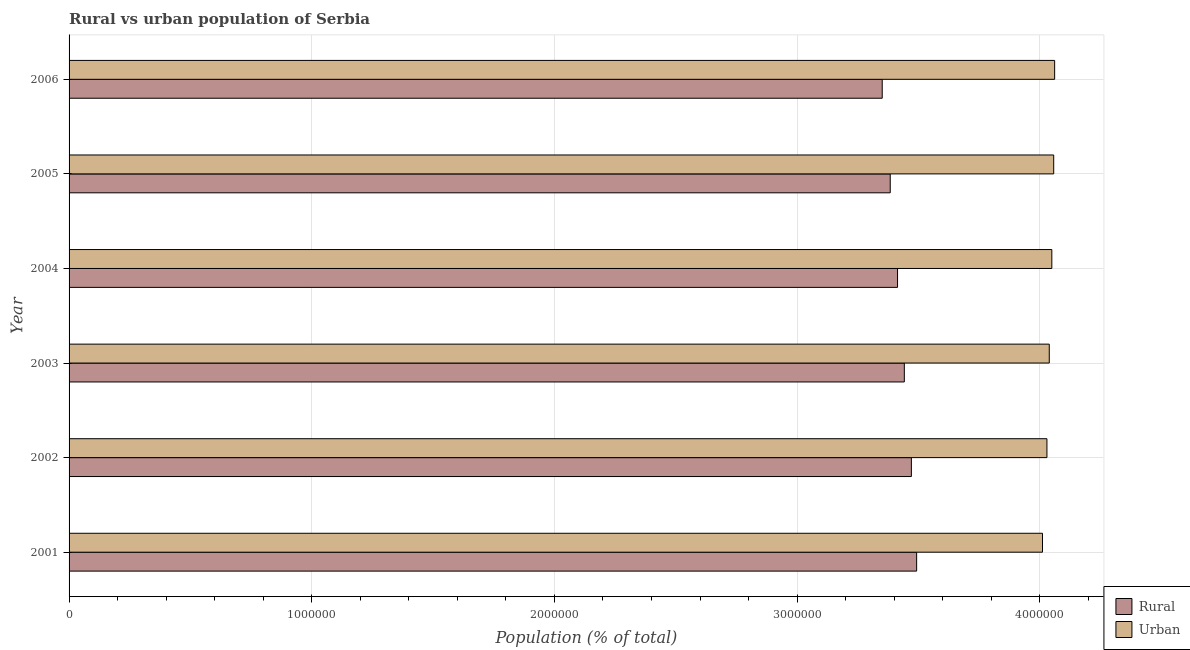How many groups of bars are there?
Offer a terse response. 6. Are the number of bars per tick equal to the number of legend labels?
Make the answer very short. Yes. Are the number of bars on each tick of the Y-axis equal?
Your answer should be compact. Yes. How many bars are there on the 1st tick from the bottom?
Your answer should be very brief. 2. What is the label of the 5th group of bars from the top?
Your answer should be very brief. 2002. In how many cases, is the number of bars for a given year not equal to the number of legend labels?
Give a very brief answer. 0. What is the urban population density in 2004?
Offer a very short reply. 4.05e+06. Across all years, what is the maximum urban population density?
Offer a terse response. 4.06e+06. Across all years, what is the minimum rural population density?
Your answer should be very brief. 3.35e+06. In which year was the urban population density maximum?
Your answer should be very brief. 2006. What is the total urban population density in the graph?
Give a very brief answer. 2.42e+07. What is the difference between the rural population density in 2001 and that in 2006?
Make the answer very short. 1.42e+05. What is the difference between the rural population density in 2004 and the urban population density in 2001?
Your answer should be very brief. -5.97e+05. What is the average urban population density per year?
Keep it short and to the point. 4.04e+06. In the year 2005, what is the difference between the urban population density and rural population density?
Your response must be concise. 6.74e+05. What is the ratio of the rural population density in 2004 to that in 2005?
Offer a very short reply. 1.01. Is the difference between the urban population density in 2001 and 2003 greater than the difference between the rural population density in 2001 and 2003?
Your response must be concise. No. What is the difference between the highest and the second highest rural population density?
Give a very brief answer. 2.17e+04. What is the difference between the highest and the lowest urban population density?
Ensure brevity in your answer.  5.00e+04. What does the 2nd bar from the top in 2006 represents?
Make the answer very short. Rural. What does the 1st bar from the bottom in 2004 represents?
Offer a very short reply. Rural. How many bars are there?
Provide a short and direct response. 12. Are all the bars in the graph horizontal?
Make the answer very short. Yes. Are the values on the major ticks of X-axis written in scientific E-notation?
Offer a terse response. No. How many legend labels are there?
Provide a short and direct response. 2. How are the legend labels stacked?
Your answer should be very brief. Vertical. What is the title of the graph?
Offer a terse response. Rural vs urban population of Serbia. Does "Urban Population" appear as one of the legend labels in the graph?
Provide a short and direct response. No. What is the label or title of the X-axis?
Make the answer very short. Population (% of total). What is the label or title of the Y-axis?
Provide a short and direct response. Year. What is the Population (% of total) in Rural in 2001?
Make the answer very short. 3.49e+06. What is the Population (% of total) of Urban in 2001?
Provide a short and direct response. 4.01e+06. What is the Population (% of total) of Rural in 2002?
Your answer should be compact. 3.47e+06. What is the Population (% of total) of Urban in 2002?
Provide a short and direct response. 4.03e+06. What is the Population (% of total) in Rural in 2003?
Offer a terse response. 3.44e+06. What is the Population (% of total) in Urban in 2003?
Your response must be concise. 4.04e+06. What is the Population (% of total) in Rural in 2004?
Your response must be concise. 3.41e+06. What is the Population (% of total) of Urban in 2004?
Your answer should be very brief. 4.05e+06. What is the Population (% of total) in Rural in 2005?
Provide a short and direct response. 3.38e+06. What is the Population (% of total) of Urban in 2005?
Your answer should be compact. 4.06e+06. What is the Population (% of total) of Rural in 2006?
Offer a terse response. 3.35e+06. What is the Population (% of total) in Urban in 2006?
Keep it short and to the point. 4.06e+06. Across all years, what is the maximum Population (% of total) in Rural?
Make the answer very short. 3.49e+06. Across all years, what is the maximum Population (% of total) in Urban?
Provide a succinct answer. 4.06e+06. Across all years, what is the minimum Population (% of total) of Rural?
Provide a succinct answer. 3.35e+06. Across all years, what is the minimum Population (% of total) of Urban?
Provide a short and direct response. 4.01e+06. What is the total Population (% of total) of Rural in the graph?
Give a very brief answer. 2.06e+07. What is the total Population (% of total) in Urban in the graph?
Make the answer very short. 2.42e+07. What is the difference between the Population (% of total) in Rural in 2001 and that in 2002?
Give a very brief answer. 2.17e+04. What is the difference between the Population (% of total) of Urban in 2001 and that in 2002?
Ensure brevity in your answer.  -1.83e+04. What is the difference between the Population (% of total) of Rural in 2001 and that in 2003?
Ensure brevity in your answer.  5.07e+04. What is the difference between the Population (% of total) in Urban in 2001 and that in 2003?
Keep it short and to the point. -2.79e+04. What is the difference between the Population (% of total) in Rural in 2001 and that in 2004?
Ensure brevity in your answer.  7.87e+04. What is the difference between the Population (% of total) of Urban in 2001 and that in 2004?
Your answer should be very brief. -3.84e+04. What is the difference between the Population (% of total) in Rural in 2001 and that in 2005?
Keep it short and to the point. 1.09e+05. What is the difference between the Population (% of total) in Urban in 2001 and that in 2005?
Provide a short and direct response. -4.61e+04. What is the difference between the Population (% of total) in Rural in 2001 and that in 2006?
Your answer should be compact. 1.42e+05. What is the difference between the Population (% of total) of Urban in 2001 and that in 2006?
Offer a terse response. -5.00e+04. What is the difference between the Population (% of total) in Rural in 2002 and that in 2003?
Provide a succinct answer. 2.90e+04. What is the difference between the Population (% of total) of Urban in 2002 and that in 2003?
Give a very brief answer. -9604. What is the difference between the Population (% of total) of Rural in 2002 and that in 2004?
Offer a terse response. 5.70e+04. What is the difference between the Population (% of total) of Urban in 2002 and that in 2004?
Your response must be concise. -2.01e+04. What is the difference between the Population (% of total) in Rural in 2002 and that in 2005?
Ensure brevity in your answer.  8.71e+04. What is the difference between the Population (% of total) in Urban in 2002 and that in 2005?
Your answer should be compact. -2.78e+04. What is the difference between the Population (% of total) of Rural in 2002 and that in 2006?
Offer a terse response. 1.20e+05. What is the difference between the Population (% of total) in Urban in 2002 and that in 2006?
Give a very brief answer. -3.17e+04. What is the difference between the Population (% of total) in Rural in 2003 and that in 2004?
Offer a very short reply. 2.79e+04. What is the difference between the Population (% of total) of Urban in 2003 and that in 2004?
Your answer should be compact. -1.05e+04. What is the difference between the Population (% of total) of Rural in 2003 and that in 2005?
Give a very brief answer. 5.81e+04. What is the difference between the Population (% of total) of Urban in 2003 and that in 2005?
Provide a short and direct response. -1.82e+04. What is the difference between the Population (% of total) of Rural in 2003 and that in 2006?
Offer a very short reply. 9.11e+04. What is the difference between the Population (% of total) in Urban in 2003 and that in 2006?
Your answer should be compact. -2.21e+04. What is the difference between the Population (% of total) of Rural in 2004 and that in 2005?
Provide a succinct answer. 3.01e+04. What is the difference between the Population (% of total) in Urban in 2004 and that in 2005?
Ensure brevity in your answer.  -7720. What is the difference between the Population (% of total) in Rural in 2004 and that in 2006?
Make the answer very short. 6.32e+04. What is the difference between the Population (% of total) of Urban in 2004 and that in 2006?
Provide a succinct answer. -1.16e+04. What is the difference between the Population (% of total) of Rural in 2005 and that in 2006?
Offer a very short reply. 3.31e+04. What is the difference between the Population (% of total) in Urban in 2005 and that in 2006?
Keep it short and to the point. -3867. What is the difference between the Population (% of total) in Rural in 2001 and the Population (% of total) in Urban in 2002?
Provide a succinct answer. -5.37e+05. What is the difference between the Population (% of total) of Rural in 2001 and the Population (% of total) of Urban in 2003?
Offer a terse response. -5.47e+05. What is the difference between the Population (% of total) in Rural in 2001 and the Population (% of total) in Urban in 2004?
Provide a short and direct response. -5.57e+05. What is the difference between the Population (% of total) in Rural in 2001 and the Population (% of total) in Urban in 2005?
Your answer should be very brief. -5.65e+05. What is the difference between the Population (% of total) in Rural in 2001 and the Population (% of total) in Urban in 2006?
Keep it short and to the point. -5.69e+05. What is the difference between the Population (% of total) of Rural in 2002 and the Population (% of total) of Urban in 2003?
Your answer should be compact. -5.68e+05. What is the difference between the Population (% of total) in Rural in 2002 and the Population (% of total) in Urban in 2004?
Your answer should be very brief. -5.79e+05. What is the difference between the Population (% of total) of Rural in 2002 and the Population (% of total) of Urban in 2005?
Your answer should be compact. -5.86e+05. What is the difference between the Population (% of total) in Rural in 2002 and the Population (% of total) in Urban in 2006?
Ensure brevity in your answer.  -5.90e+05. What is the difference between the Population (% of total) of Rural in 2003 and the Population (% of total) of Urban in 2004?
Your answer should be compact. -6.08e+05. What is the difference between the Population (% of total) in Rural in 2003 and the Population (% of total) in Urban in 2005?
Offer a very short reply. -6.15e+05. What is the difference between the Population (% of total) in Rural in 2003 and the Population (% of total) in Urban in 2006?
Keep it short and to the point. -6.19e+05. What is the difference between the Population (% of total) of Rural in 2004 and the Population (% of total) of Urban in 2005?
Offer a very short reply. -6.43e+05. What is the difference between the Population (% of total) in Rural in 2004 and the Population (% of total) in Urban in 2006?
Your answer should be compact. -6.47e+05. What is the difference between the Population (% of total) of Rural in 2005 and the Population (% of total) of Urban in 2006?
Offer a very short reply. -6.77e+05. What is the average Population (% of total) in Rural per year?
Offer a very short reply. 3.43e+06. What is the average Population (% of total) of Urban per year?
Offer a terse response. 4.04e+06. In the year 2001, what is the difference between the Population (% of total) in Rural and Population (% of total) in Urban?
Your response must be concise. -5.19e+05. In the year 2002, what is the difference between the Population (% of total) in Rural and Population (% of total) in Urban?
Your answer should be very brief. -5.59e+05. In the year 2003, what is the difference between the Population (% of total) of Rural and Population (% of total) of Urban?
Make the answer very short. -5.97e+05. In the year 2004, what is the difference between the Population (% of total) in Rural and Population (% of total) in Urban?
Offer a very short reply. -6.36e+05. In the year 2005, what is the difference between the Population (% of total) of Rural and Population (% of total) of Urban?
Your response must be concise. -6.74e+05. In the year 2006, what is the difference between the Population (% of total) of Rural and Population (% of total) of Urban?
Your answer should be very brief. -7.10e+05. What is the ratio of the Population (% of total) in Urban in 2001 to that in 2002?
Your answer should be compact. 1. What is the ratio of the Population (% of total) of Rural in 2001 to that in 2003?
Your answer should be very brief. 1.01. What is the ratio of the Population (% of total) of Urban in 2001 to that in 2003?
Offer a terse response. 0.99. What is the ratio of the Population (% of total) of Rural in 2001 to that in 2005?
Provide a succinct answer. 1.03. What is the ratio of the Population (% of total) in Rural in 2001 to that in 2006?
Provide a short and direct response. 1.04. What is the ratio of the Population (% of total) in Urban in 2001 to that in 2006?
Make the answer very short. 0.99. What is the ratio of the Population (% of total) of Rural in 2002 to that in 2003?
Provide a short and direct response. 1.01. What is the ratio of the Population (% of total) in Rural in 2002 to that in 2004?
Make the answer very short. 1.02. What is the ratio of the Population (% of total) of Urban in 2002 to that in 2004?
Your response must be concise. 0.99. What is the ratio of the Population (% of total) in Rural in 2002 to that in 2005?
Ensure brevity in your answer.  1.03. What is the ratio of the Population (% of total) of Urban in 2002 to that in 2005?
Your answer should be very brief. 0.99. What is the ratio of the Population (% of total) in Rural in 2002 to that in 2006?
Offer a very short reply. 1.04. What is the ratio of the Population (% of total) in Urban in 2002 to that in 2006?
Give a very brief answer. 0.99. What is the ratio of the Population (% of total) of Rural in 2003 to that in 2004?
Give a very brief answer. 1.01. What is the ratio of the Population (% of total) in Rural in 2003 to that in 2005?
Offer a very short reply. 1.02. What is the ratio of the Population (% of total) in Urban in 2003 to that in 2005?
Make the answer very short. 1. What is the ratio of the Population (% of total) in Rural in 2003 to that in 2006?
Offer a terse response. 1.03. What is the ratio of the Population (% of total) of Urban in 2003 to that in 2006?
Your answer should be very brief. 0.99. What is the ratio of the Population (% of total) in Rural in 2004 to that in 2005?
Keep it short and to the point. 1.01. What is the ratio of the Population (% of total) in Urban in 2004 to that in 2005?
Provide a short and direct response. 1. What is the ratio of the Population (% of total) in Rural in 2004 to that in 2006?
Ensure brevity in your answer.  1.02. What is the ratio of the Population (% of total) in Urban in 2004 to that in 2006?
Provide a short and direct response. 1. What is the ratio of the Population (% of total) of Rural in 2005 to that in 2006?
Offer a terse response. 1.01. What is the ratio of the Population (% of total) of Urban in 2005 to that in 2006?
Make the answer very short. 1. What is the difference between the highest and the second highest Population (% of total) in Rural?
Offer a terse response. 2.17e+04. What is the difference between the highest and the second highest Population (% of total) in Urban?
Provide a succinct answer. 3867. What is the difference between the highest and the lowest Population (% of total) of Rural?
Ensure brevity in your answer.  1.42e+05. What is the difference between the highest and the lowest Population (% of total) in Urban?
Make the answer very short. 5.00e+04. 